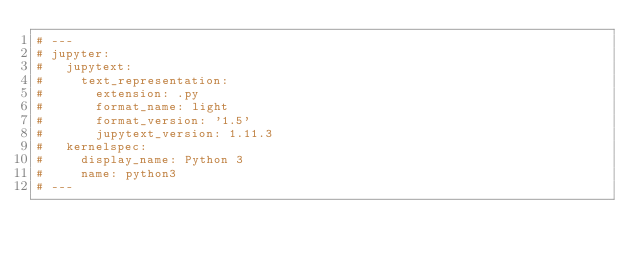<code> <loc_0><loc_0><loc_500><loc_500><_Python_># ---
# jupyter:
#   jupytext:
#     text_representation:
#       extension: .py
#       format_name: light
#       format_version: '1.5'
#       jupytext_version: 1.11.3
#   kernelspec:
#     display_name: Python 3
#     name: python3
# ---
</code> 